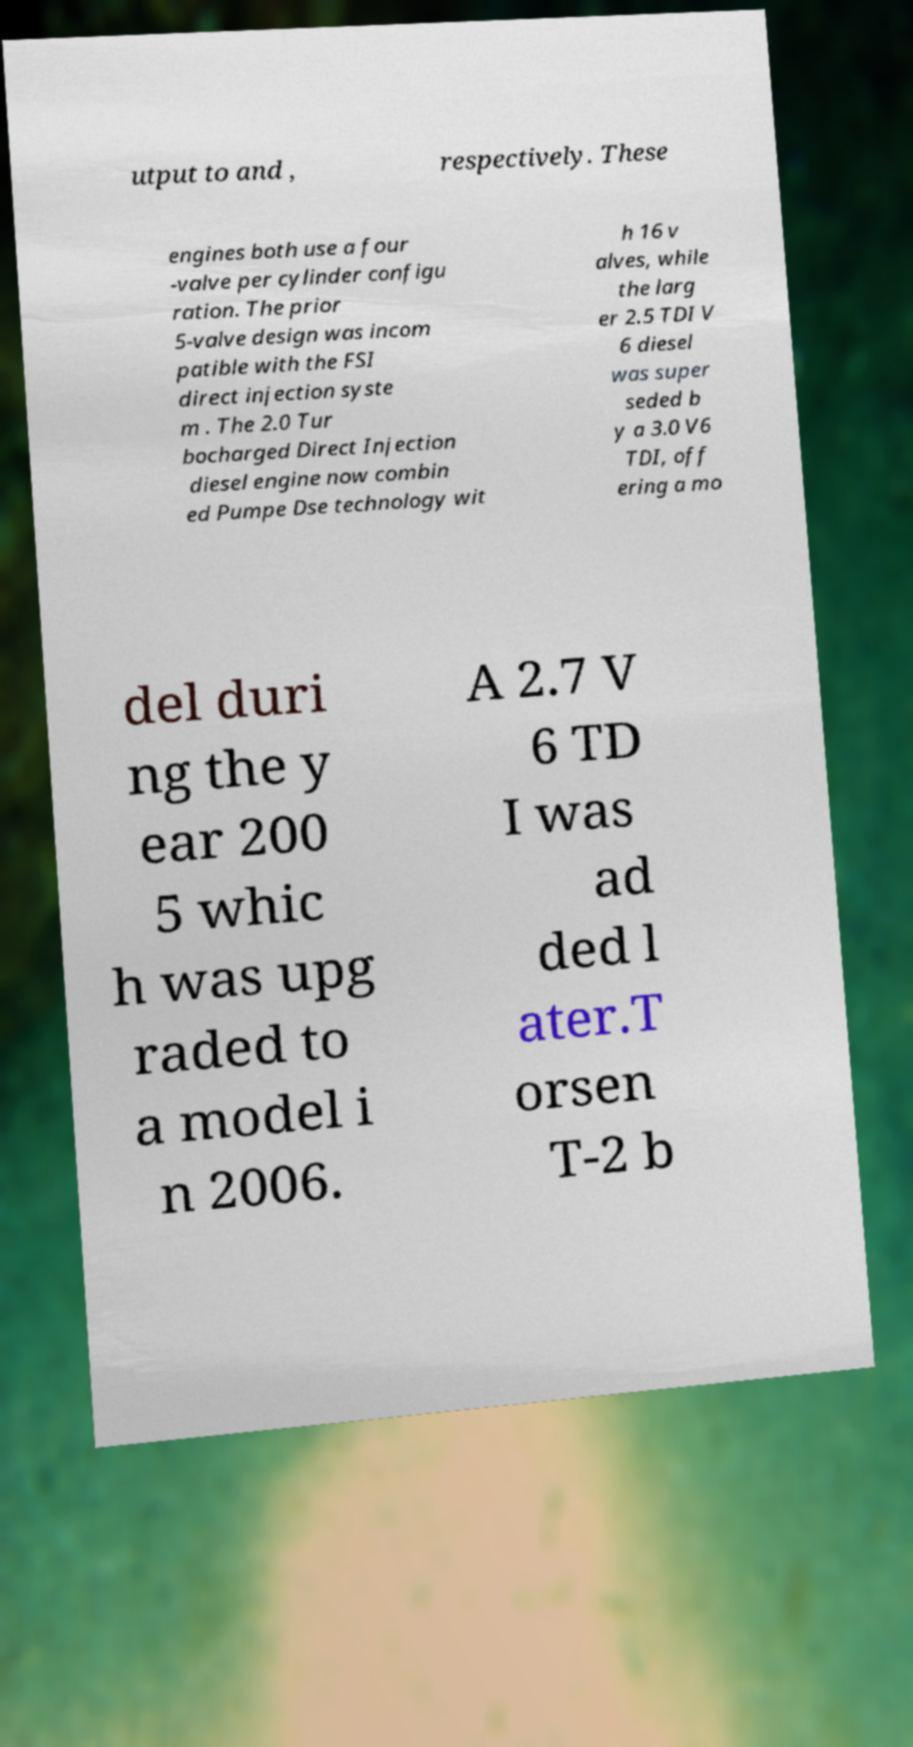Can you accurately transcribe the text from the provided image for me? utput to and , respectively. These engines both use a four -valve per cylinder configu ration. The prior 5-valve design was incom patible with the FSI direct injection syste m . The 2.0 Tur bocharged Direct Injection diesel engine now combin ed Pumpe Dse technology wit h 16 v alves, while the larg er 2.5 TDI V 6 diesel was super seded b y a 3.0 V6 TDI, off ering a mo del duri ng the y ear 200 5 whic h was upg raded to a model i n 2006. A 2.7 V 6 TD I was ad ded l ater.T orsen T-2 b 